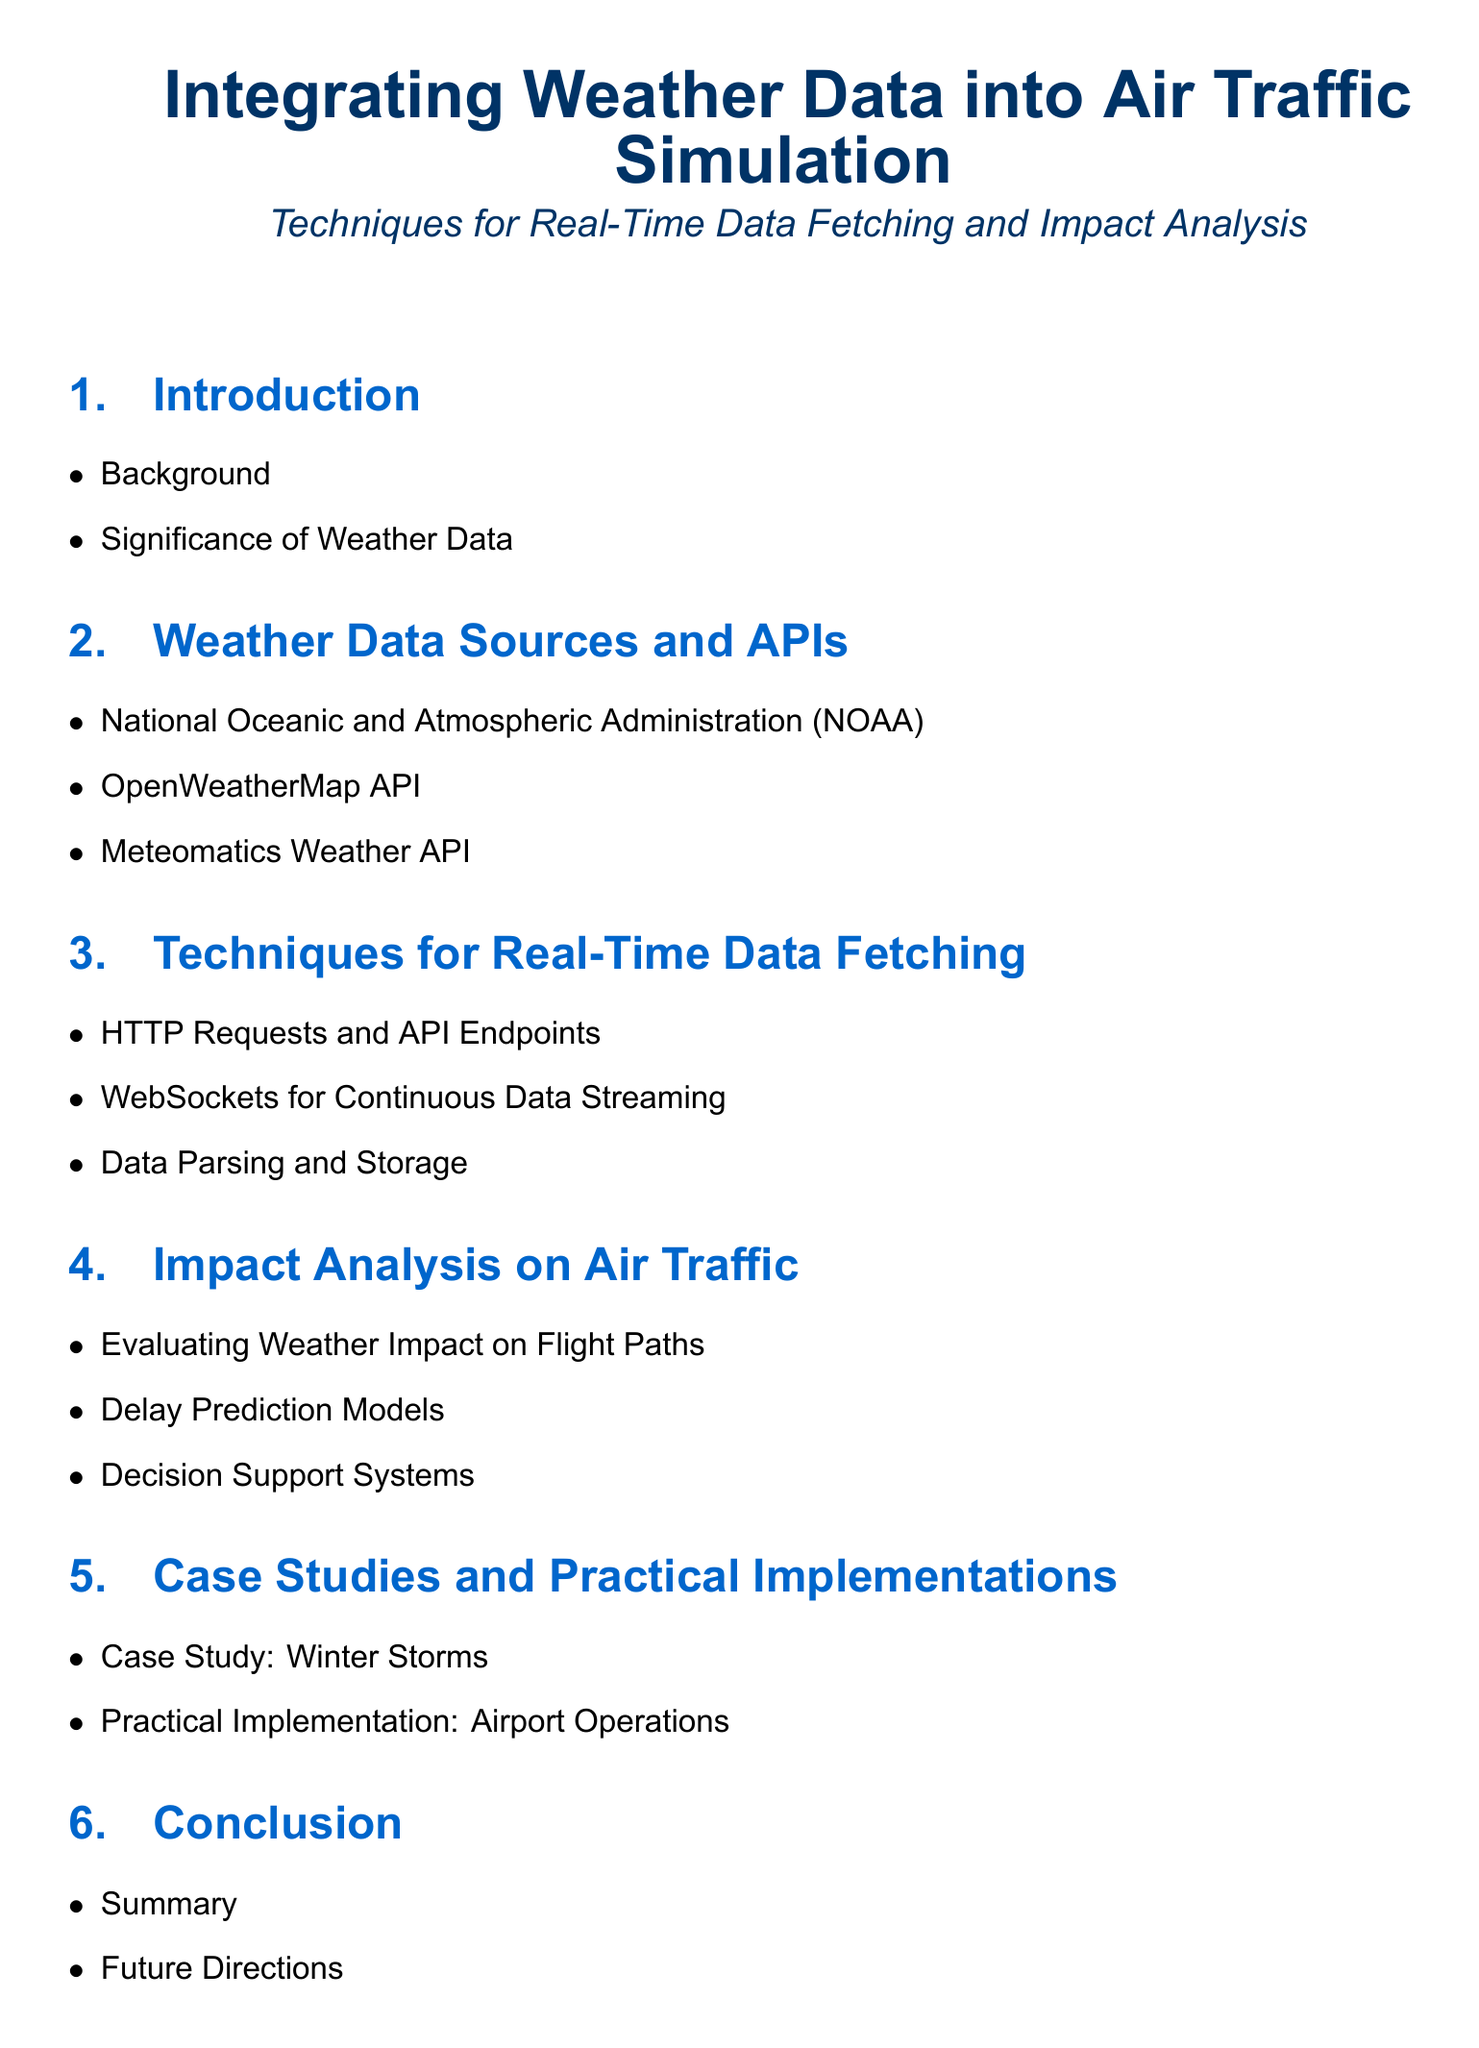What is the title of the document? The title appears in a large font at the center of the document, which is "Integrating Weather Data into Air Traffic Simulation".
Answer: Integrating Weather Data into Air Traffic Simulation What is one source of weather data mentioned? The document lists several sources and APIs for weather data, one of which is the National Oceanic and Atmospheric Administration.
Answer: National Oceanic and Atmospheric Administration What technique is used for continuous data streaming? The document specifies that WebSockets can be used for continuous data streaming in the section on real-time data fetching.
Answer: WebSockets What are delay prediction models used for? Delay prediction models are mentioned in the context of analyzing the impact of weather on air traffic, specifically for predicting delays.
Answer: Predicting delays Which case study is included in the document? The document includes a case study on winter storms, highlighting its importance in air traffic simulations.
Answer: Winter Storms What is the significance of integrating weather data? The introduction addresses the significance of weather data, emphasizing its impact on safety and efficiency in air traffic.
Answer: Safety and efficiency What section discusses 'Decision Support Systems'? The section that discusses 'Decision Support Systems' is under the Impact Analysis on Air Traffic.
Answer: Impact Analysis on Air Traffic How many main sections are in the document? The document consists of six main sections, including the Introduction and Conclusion.
Answer: Six 